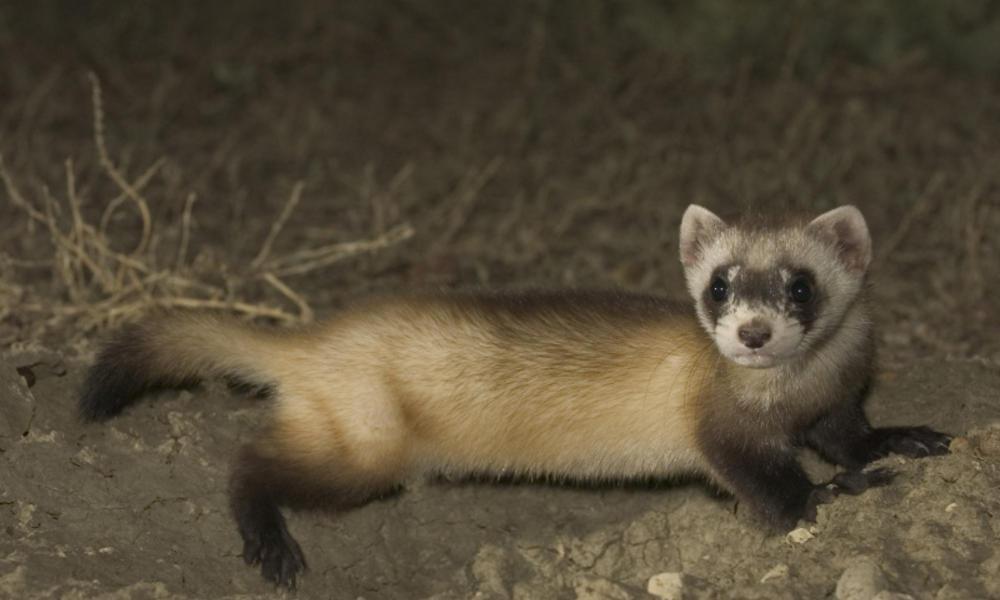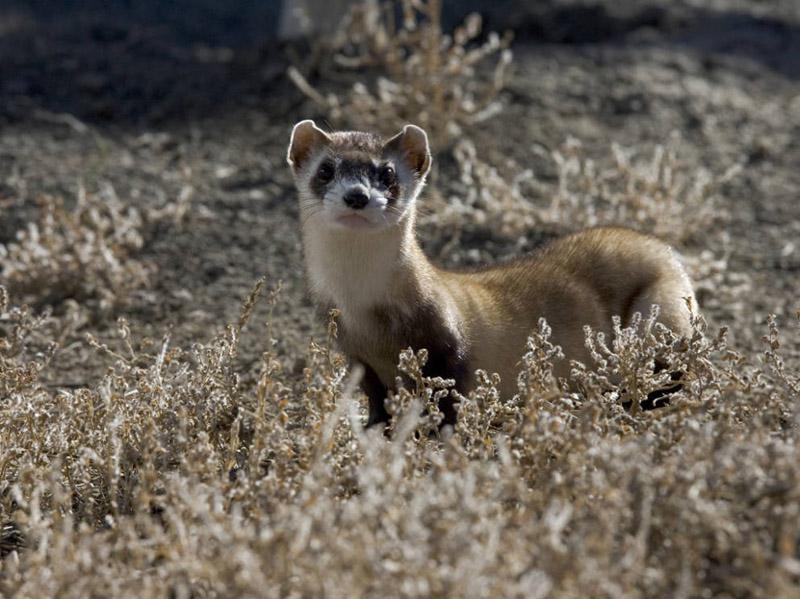The first image is the image on the left, the second image is the image on the right. Evaluate the accuracy of this statement regarding the images: "The ferret is seen coming out of a hole in the image on the right.". Is it true? Answer yes or no. No. 